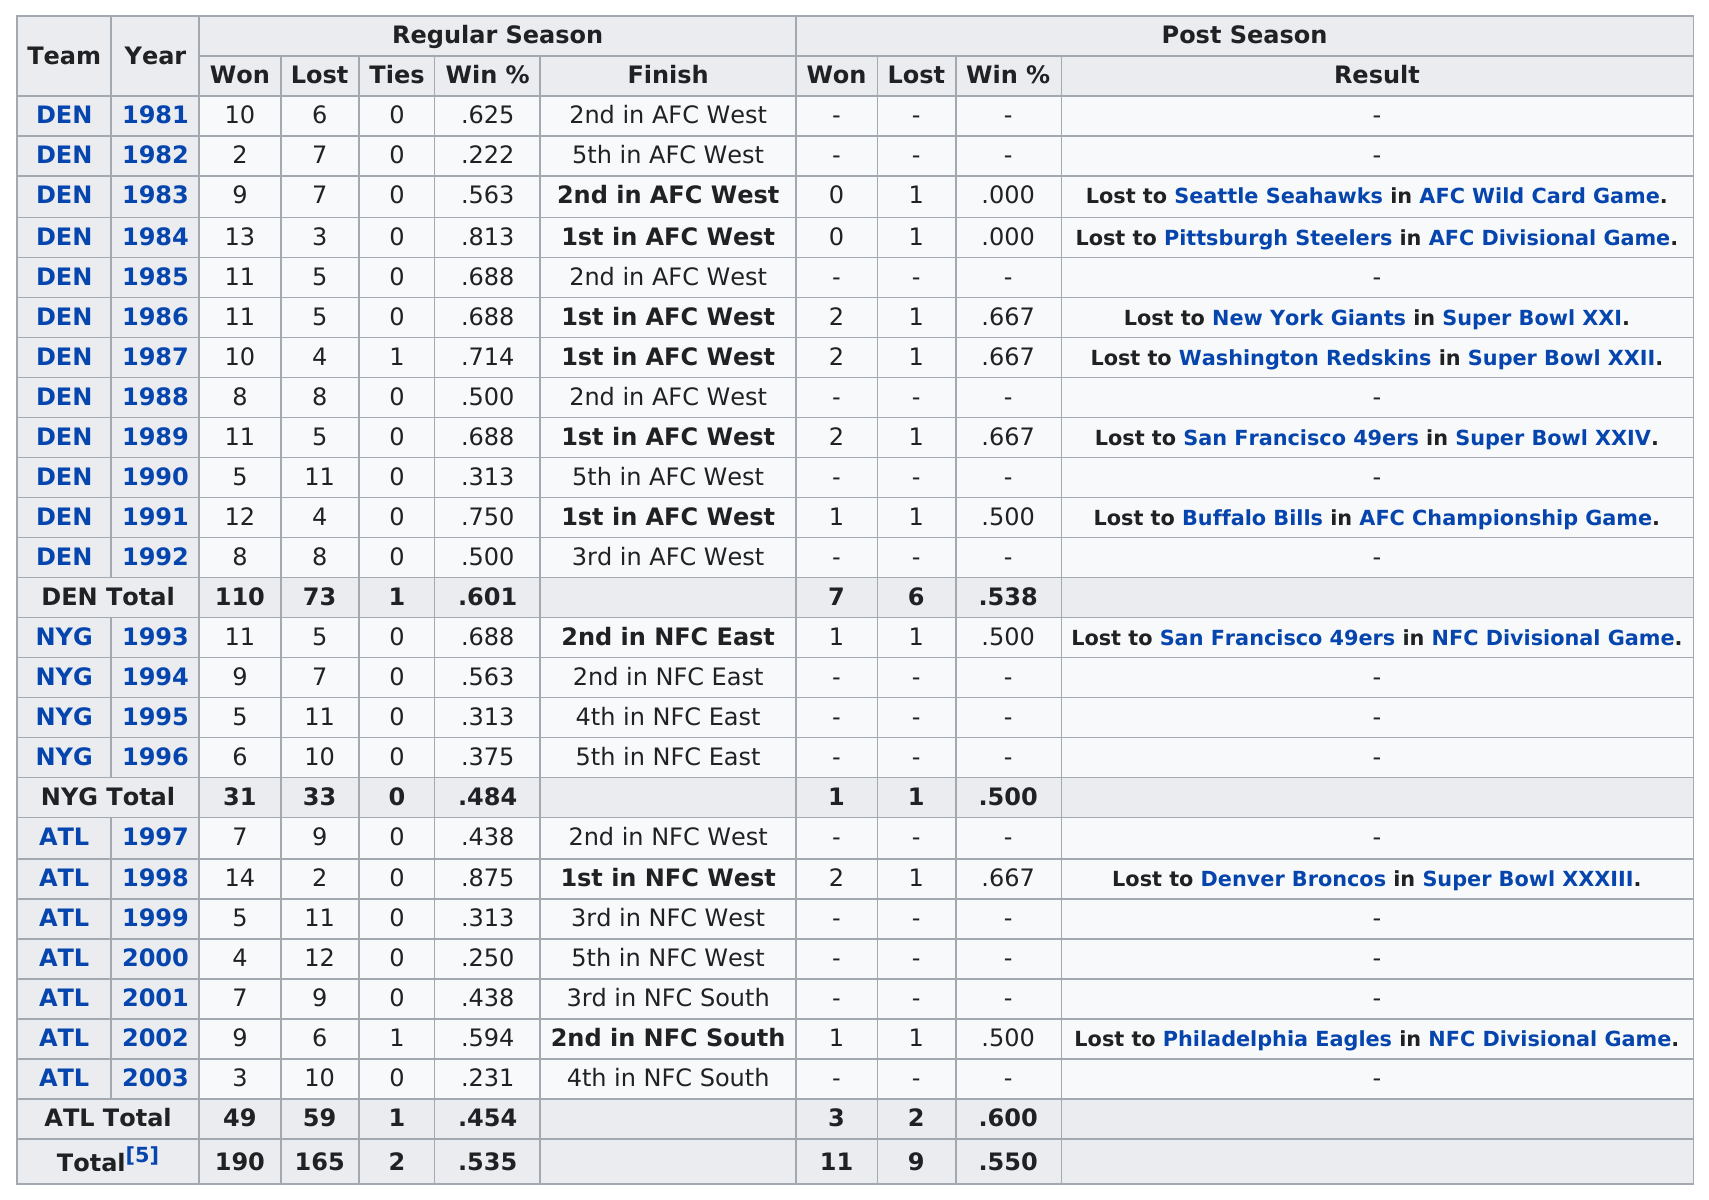Identify some key points in this picture. Dan Reeves did not win any Super Bowls. 